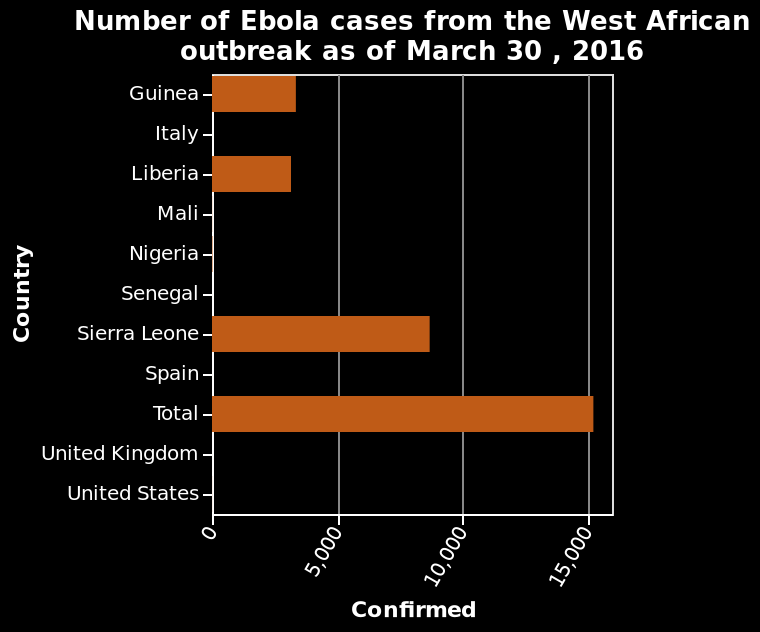<image>
What is the specific outbreak mentioned in the figure?  The specific outbreak mentioned in the figure is the West African outbreak. Which country has the most number of bars?  Sierra Leone has the most number of bars. How does the number of bars in Liberia compare to Sierra Leone? The number of bars in Liberia is approximately half of the number of bars in Sierra Leone. 